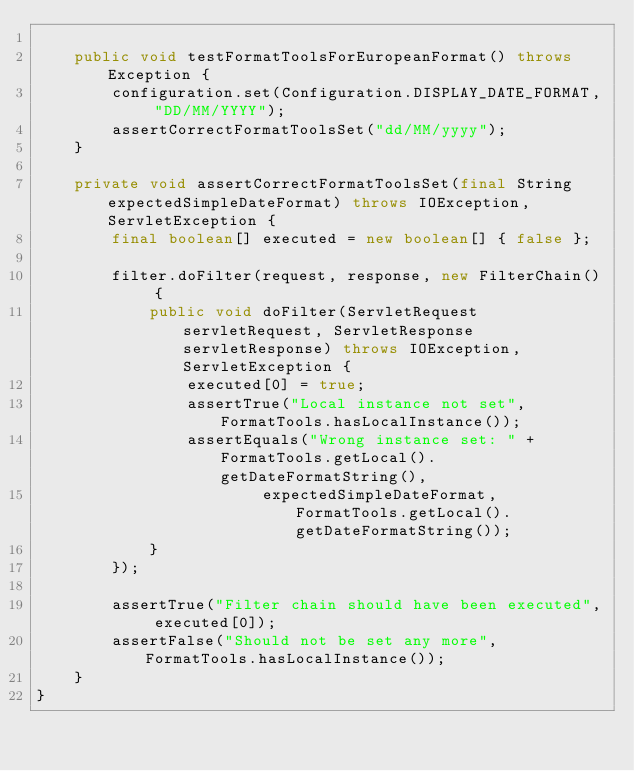<code> <loc_0><loc_0><loc_500><loc_500><_Java_>
    public void testFormatToolsForEuropeanFormat() throws Exception {
        configuration.set(Configuration.DISPLAY_DATE_FORMAT, "DD/MM/YYYY");
        assertCorrectFormatToolsSet("dd/MM/yyyy");
    }

    private void assertCorrectFormatToolsSet(final String expectedSimpleDateFormat) throws IOException, ServletException {
        final boolean[] executed = new boolean[] { false };

        filter.doFilter(request, response, new FilterChain() {
            public void doFilter(ServletRequest servletRequest, ServletResponse servletResponse) throws IOException, ServletException {
                executed[0] = true;
                assertTrue("Local instance not set", FormatTools.hasLocalInstance());
                assertEquals("Wrong instance set: " + FormatTools.getLocal().getDateFormatString(),
                        expectedSimpleDateFormat, FormatTools.getLocal().getDateFormatString());
            }
        });

        assertTrue("Filter chain should have been executed", executed[0]);
        assertFalse("Should not be set any more", FormatTools.hasLocalInstance());
    }
}
</code> 